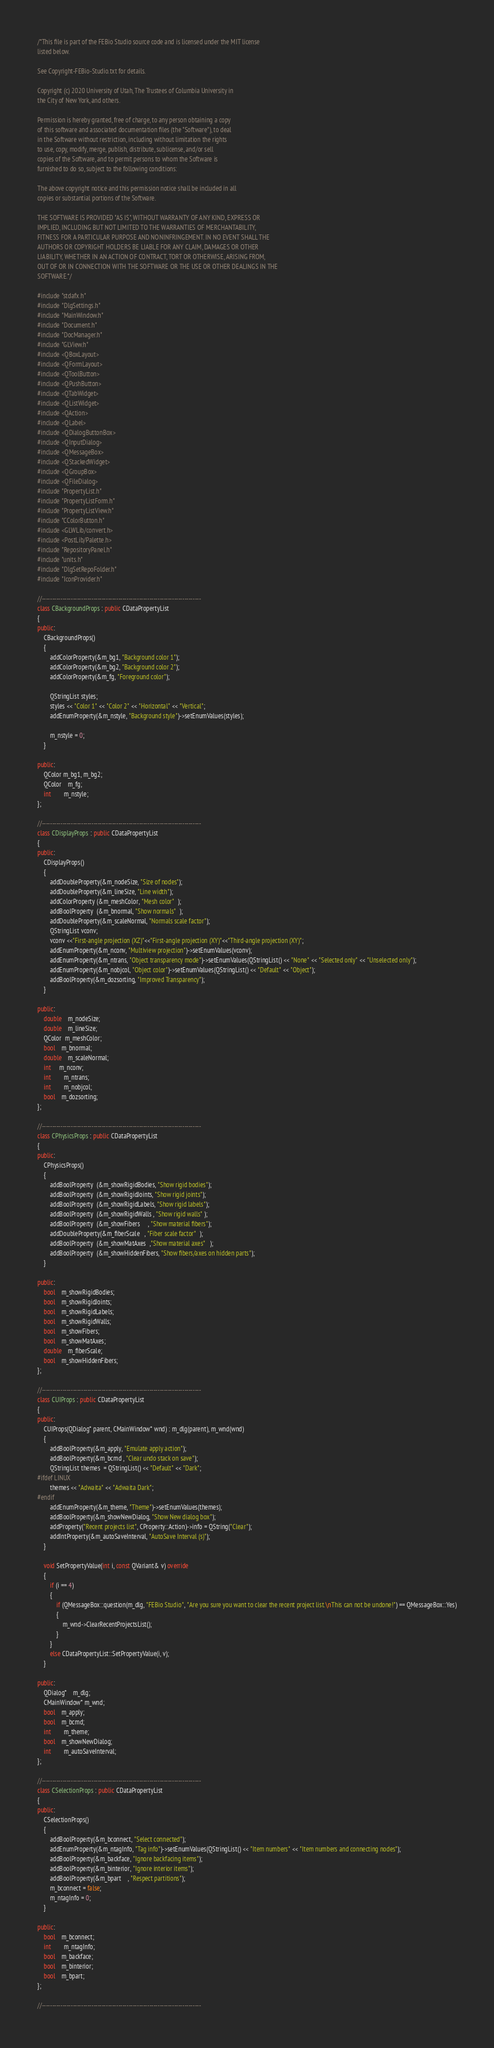Convert code to text. <code><loc_0><loc_0><loc_500><loc_500><_C++_>/*This file is part of the FEBio Studio source code and is licensed under the MIT license
listed below.

See Copyright-FEBio-Studio.txt for details.

Copyright (c) 2020 University of Utah, The Trustees of Columbia University in 
the City of New York, and others.

Permission is hereby granted, free of charge, to any person obtaining a copy
of this software and associated documentation files (the "Software"), to deal
in the Software without restriction, including without limitation the rights
to use, copy, modify, merge, publish, distribute, sublicense, and/or sell
copies of the Software, and to permit persons to whom the Software is
furnished to do so, subject to the following conditions:

The above copyright notice and this permission notice shall be included in all
copies or substantial portions of the Software.

THE SOFTWARE IS PROVIDED "AS IS", WITHOUT WARRANTY OF ANY KIND, EXPRESS OR
IMPLIED, INCLUDING BUT NOT LIMITED TO THE WARRANTIES OF MERCHANTABILITY,
FITNESS FOR A PARTICULAR PURPOSE AND NONINFRINGEMENT. IN NO EVENT SHALL THE
AUTHORS OR COPYRIGHT HOLDERS BE LIABLE FOR ANY CLAIM, DAMAGES OR OTHER
LIABILITY, WHETHER IN AN ACTION OF CONTRACT, TORT OR OTHERWISE, ARISING FROM,
OUT OF OR IN CONNECTION WITH THE SOFTWARE OR THE USE OR OTHER DEALINGS IN THE
SOFTWARE.*/

#include "stdafx.h"
#include "DlgSettings.h"
#include "MainWindow.h"
#include "Document.h"
#include "DocManager.h"
#include "GLView.h"
#include <QBoxLayout>
#include <QFormLayout>
#include <QToolButton>
#include <QPushButton>
#include <QTabWidget>
#include <QListWidget>
#include <QAction>
#include <QLabel>
#include <QDialogButtonBox>
#include <QInputDialog>
#include <QMessageBox>
#include <QStackedWidget>
#include <QGroupBox>
#include <QFileDialog>
#include "PropertyList.h"
#include "PropertyListForm.h"
#include "PropertyListView.h"
#include "CColorButton.h"
#include <GLWLib/convert.h>
#include <PostLib/Palette.h>
#include "RepositoryPanel.h"
#include "units.h"
#include "DlgSetRepoFolder.h"
#include "IconProvider.h"

//-----------------------------------------------------------------------------
class CBackgroundProps : public CDataPropertyList
{
public:
	CBackgroundProps()
	{
		addColorProperty(&m_bg1, "Background color 1");
		addColorProperty(&m_bg2, "Background color 2");
		addColorProperty(&m_fg, "Foreground color");

		QStringList styles;
		styles << "Color 1" << "Color 2" << "Horizontal" << "Vertical";
		addEnumProperty(&m_nstyle, "Background style")->setEnumValues(styles);

		m_nstyle = 0;
	}

public:
	QColor m_bg1, m_bg2;
	QColor	m_fg;
	int		m_nstyle;
};

//-----------------------------------------------------------------------------
class CDisplayProps : public CDataPropertyList
{
public:
	CDisplayProps()
	{
		addDoubleProperty(&m_nodeSize, "Size of nodes");
		addDoubleProperty(&m_lineSize, "Line width");
		addColorProperty (&m_meshColor, "Mesh color"  );
		addBoolProperty  (&m_bnormal, "Show normals"  );
		addDoubleProperty(&m_scaleNormal, "Normals scale factor");
        QStringList vconv;
        vconv <<"First-angle projection (XZ)"<<"First-angle projection (XY)"<<"Third-angle projection (XY)";
        addEnumProperty(&m_nconv, "Multiview projection")->setEnumValues(vconv);
		addEnumProperty(&m_ntrans, "Object transparency mode")->setEnumValues(QStringList() << "None" << "Selected only" << "Unselected only");
		addEnumProperty(&m_nobjcol, "Object color")->setEnumValues(QStringList() << "Default" << "Object");
		addBoolProperty(&m_dozsorting, "Improved Transparency");
	}

public:
	double	m_nodeSize;
	double	m_lineSize;
	QColor  m_meshColor;
	bool	m_bnormal;
	double	m_scaleNormal;
    int     m_nconv;
	int		m_ntrans;
	int		m_nobjcol;
	bool	m_dozsorting;
};

//-----------------------------------------------------------------------------
class CPhysicsProps : public CDataPropertyList
{
public:
	CPhysicsProps()
	{
		addBoolProperty  (&m_showRigidBodies, "Show rigid bodies");
		addBoolProperty  (&m_showRigidJoints, "Show rigid joints");
		addBoolProperty  (&m_showRigidLabels, "Show rigid labels");
		addBoolProperty  (&m_showRigidWalls , "Show rigid walls" );
		addBoolProperty  (&m_showFibers     , "Show material fibers");
		addDoubleProperty(&m_fiberScale   , "Fiber scale factor"  );
		addBoolProperty  (&m_showMatAxes  ,"Show material axes"   );
		addBoolProperty  (&m_showHiddenFibers, "Show fibers/axes on hidden parts");
	}

public:
	bool	m_showRigidBodies;
	bool	m_showRigidJoints;
	bool	m_showRigidLabels;
	bool	m_showRigidWalls;
	bool	m_showFibers;
	bool	m_showMatAxes;
	double	m_fiberScale;
	bool	m_showHiddenFibers;
};

//-----------------------------------------------------------------------------
class CUIProps : public CDataPropertyList
{
public:
	CUIProps(QDialog* parent, CMainWindow* wnd) : m_dlg(parent), m_wnd(wnd)
	{
		addBoolProperty(&m_apply, "Emulate apply action");
		addBoolProperty(&m_bcmd , "Clear undo stack on save");
		QStringList themes  = QStringList() << "Default" << "Dark";
#ifdef LINUX
		themes << "Adwaita" << "Adwaita Dark";
#endif
		addEnumProperty(&m_theme, "Theme")->setEnumValues(themes);
		addBoolProperty(&m_showNewDialog, "Show New dialog box");
		addProperty("Recent projects list", CProperty::Action)->info = QString("Clear");
		addIntProperty(&m_autoSaveInterval, "AutoSave Interval (s)");
	}

	void SetPropertyValue(int i, const QVariant& v) override
	{
		if (i == 4)
		{
			if (QMessageBox::question(m_dlg, "FEBio Studio", "Are you sure you want to clear the recent project list.\nThis can not be undone!") == QMessageBox::Yes)
			{
				m_wnd->ClearRecentProjectsList();
			}
		}
		else CDataPropertyList::SetPropertyValue(i, v);
	}

public:
	QDialog*	m_dlg;
	CMainWindow* m_wnd;
	bool	m_apply;
	bool	m_bcmd;
	int		m_theme;
	bool	m_showNewDialog;
	int		m_autoSaveInterval;
};

//-----------------------------------------------------------------------------
class CSelectionProps : public CDataPropertyList
{
public:
	CSelectionProps()
	{
		addBoolProperty(&m_bconnect, "Select connected");
		addEnumProperty(&m_ntagInfo, "Tag info")->setEnumValues(QStringList() << "Item numbers" << "Item numbers and connecting nodes");
		addBoolProperty(&m_backface, "Ignore backfacing items");
		addBoolProperty(&m_binterior, "Ignore interior items");
		addBoolProperty(&m_bpart    , "Respect partitions");
		m_bconnect = false;
		m_ntagInfo = 0;
	}

public:
	bool	m_bconnect;
	int		m_ntagInfo;
	bool	m_backface;
	bool	m_binterior;
	bool	m_bpart;
};

//-----------------------------------------------------------------------------</code> 